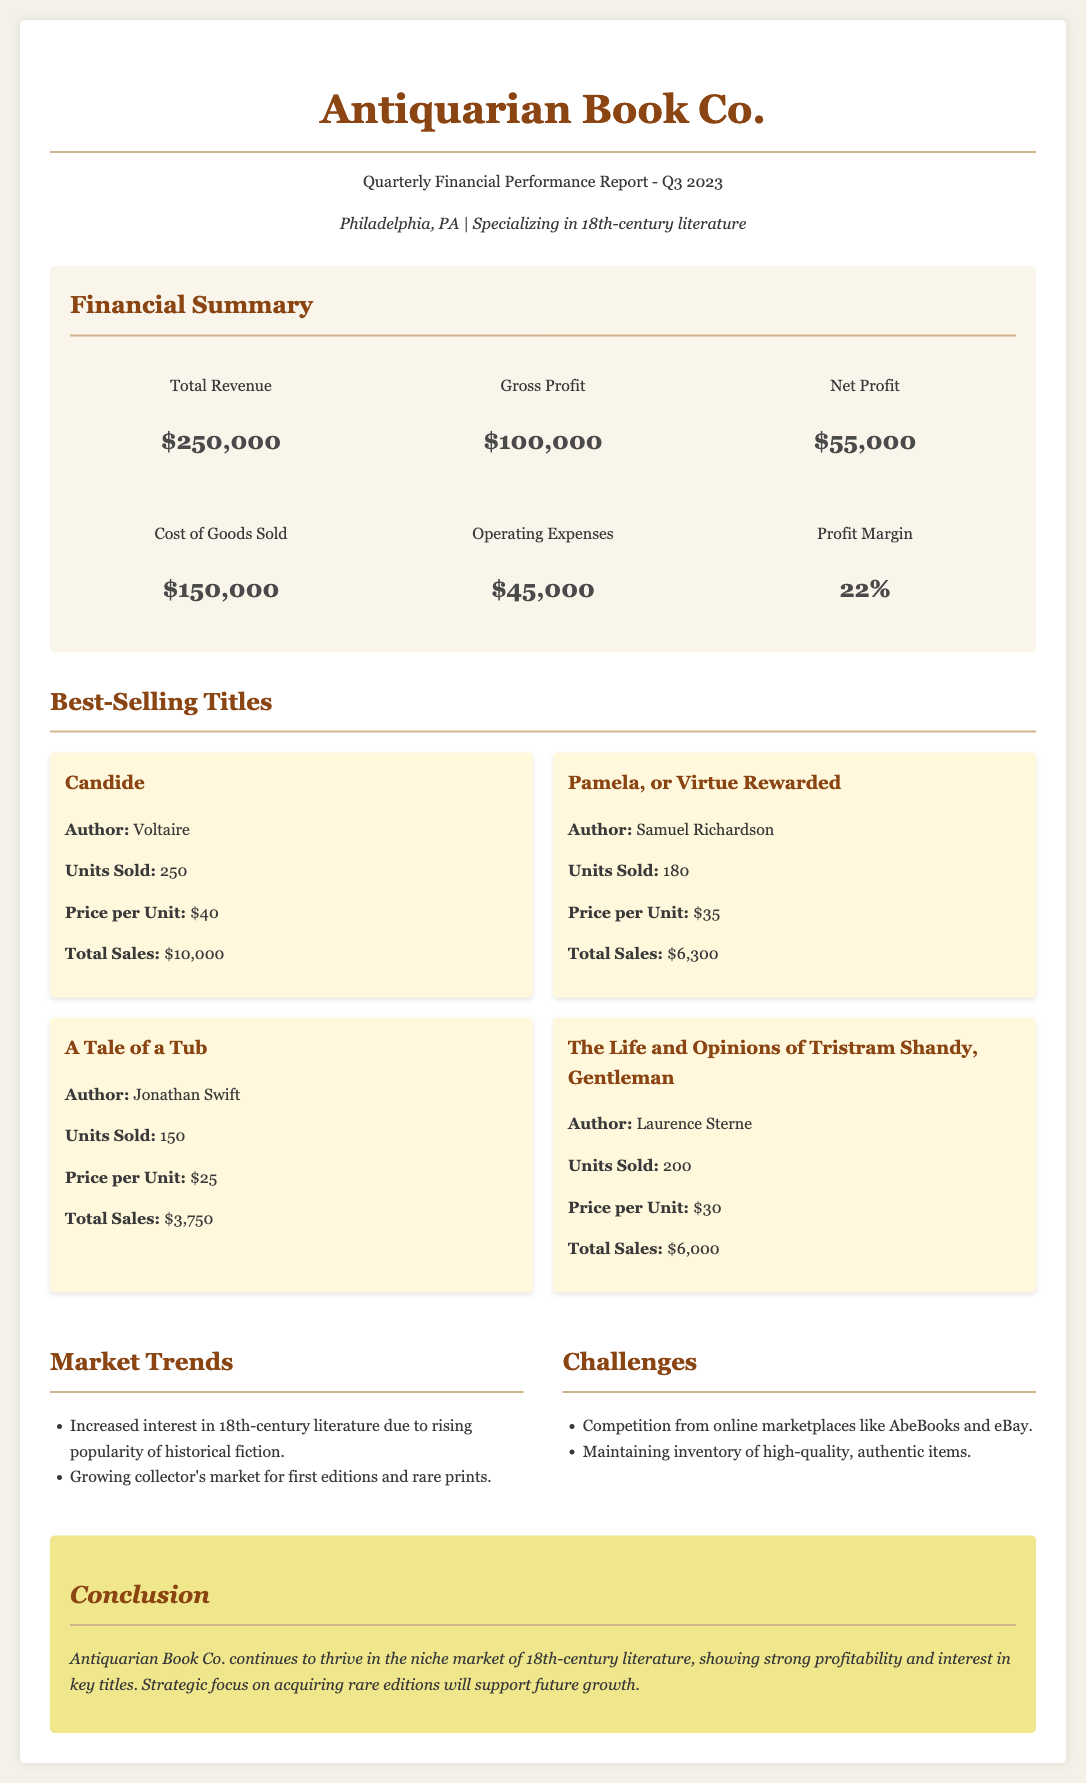What is the total revenue? The total revenue is reported in the financial summary section of the document, which states "$250,000."
Answer: $250,000 What is the net profit? The net profit can be found in the financial summary, specifically listed as "$55,000."
Answer: $55,000 How many units of "Candide" were sold? The document lists the sales section of "Candide," detailing that "250" units were sold.
Answer: 250 What is the gross profit for Q3 2023? The financial summary indicates that the gross profit for the quarter is "$100,000."
Answer: $100,000 What is the profit margin percentage? The profit margin is presented in the summary section of the document, noted as "22%."
Answer: 22% Which title had the highest total sales? The highest total sales title is shown in the best-selling titles, which is "Candide" with total sales of "$10,000."
Answer: Candide What are two challenges mentioned in the market analysis? The market analysis section outlines challenges including "Competition from online marketplaces" and "Maintaining inventory of high-quality, authentic items."
Answer: Competition from online marketplaces; Maintaining inventory of high-quality, authentic items How many best-selling titles are listed? A count of the best-selling titles in the document shows there are "four" listed.
Answer: Four What was the operating expenses amount? The operating expenses are detailed in the financial summary as "$45,000."
Answer: $45,000 